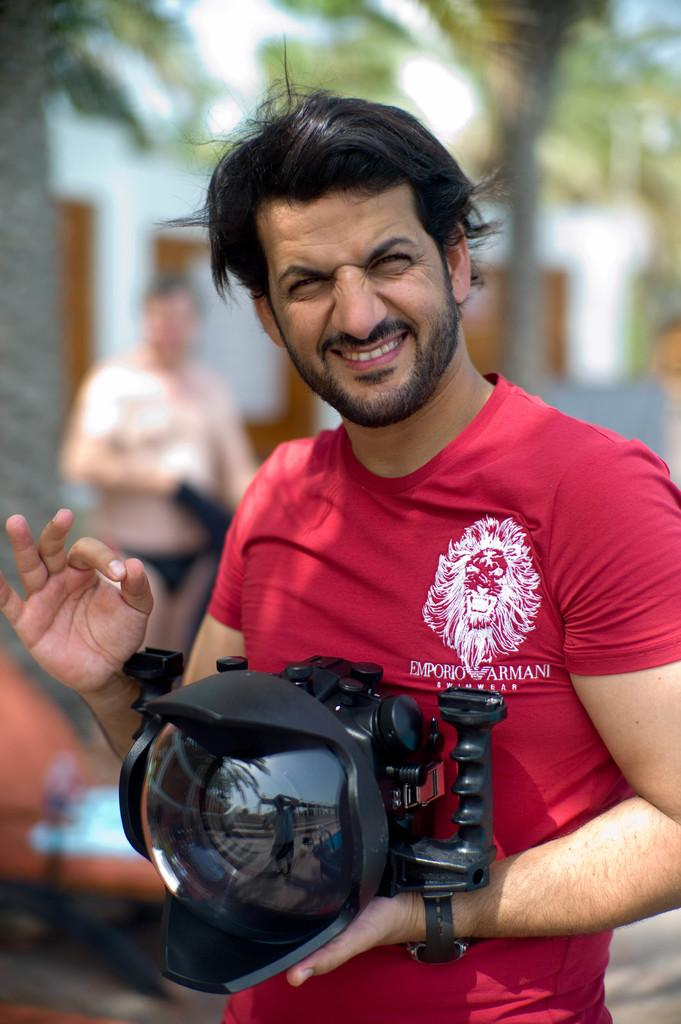What is the man in the image doing? The man is smiling in the image. What is the man wearing? The man is wearing a red T-shirt. What is the man holding in his hand? The man is holding a camera in his hand. Can you describe the background of the image? There is another person and a tree in the background of the image, and the background is blurry. How many monkeys are visible in the image? There are no monkeys present in the image. What type of chain is the man holding in the image? There is no chain present in the image. 